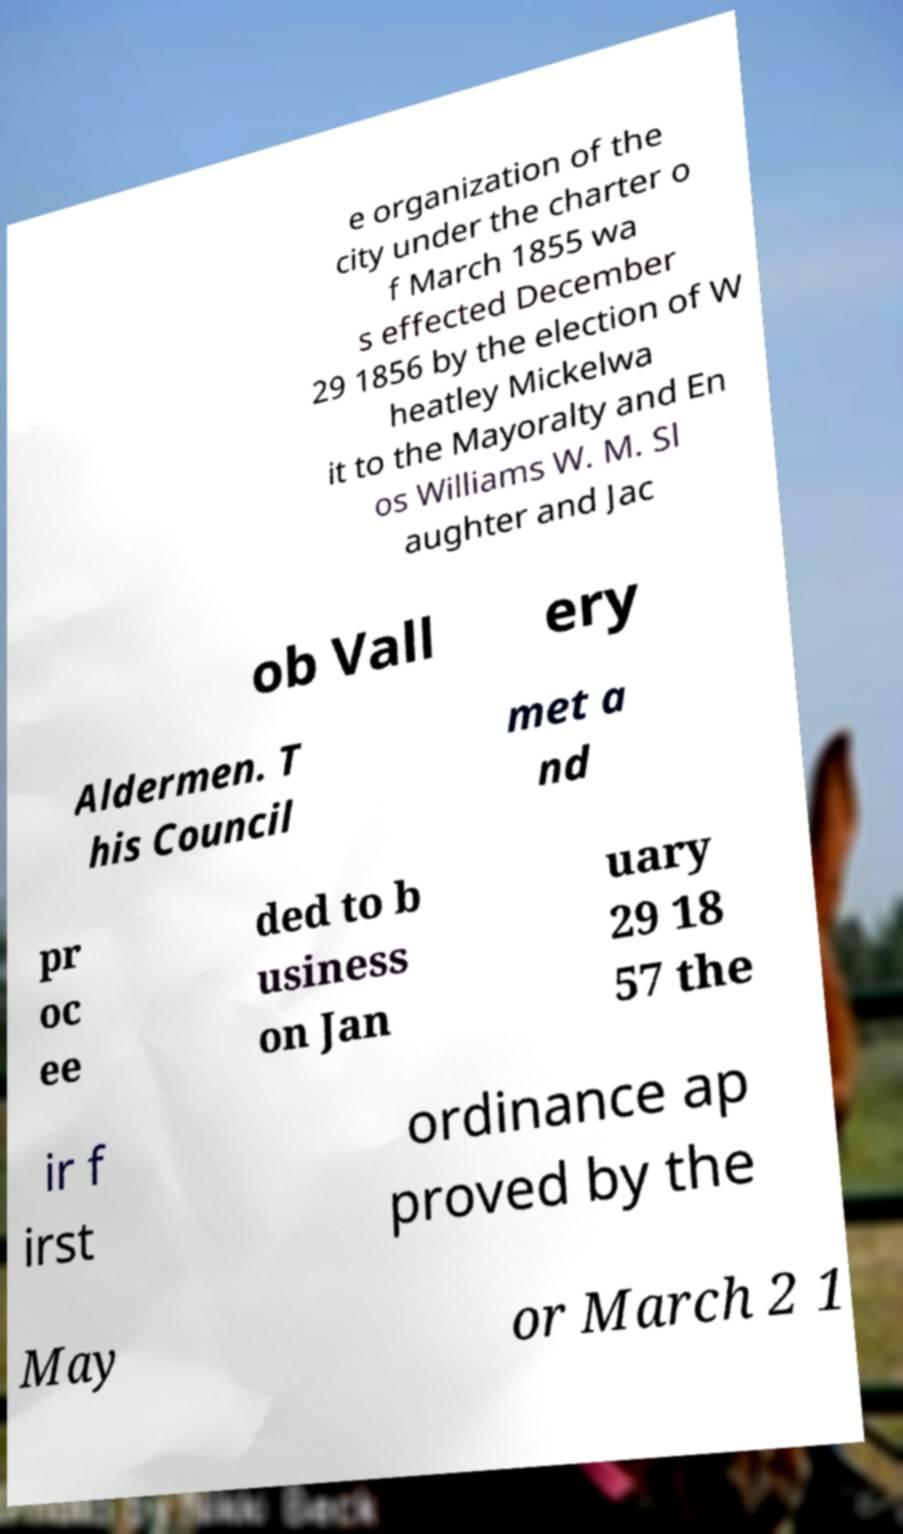Please identify and transcribe the text found in this image. e organization of the city under the charter o f March 1855 wa s effected December 29 1856 by the election of W heatley Mickelwa it to the Mayoralty and En os Williams W. M. Sl aughter and Jac ob Vall ery Aldermen. T his Council met a nd pr oc ee ded to b usiness on Jan uary 29 18 57 the ir f irst ordinance ap proved by the May or March 2 1 